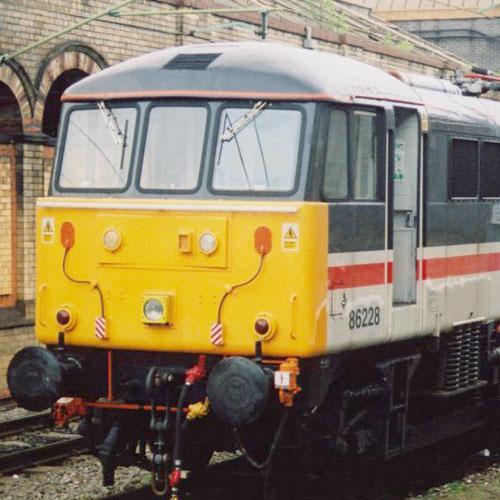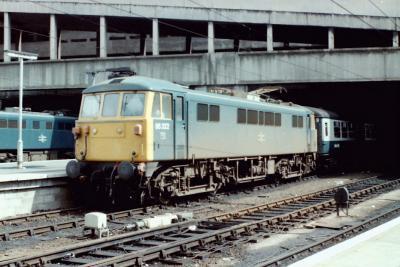The first image is the image on the left, the second image is the image on the right. Evaluate the accuracy of this statement regarding the images: "The area on the front bottom of the train in the image on the left is yellow.". Is it true? Answer yes or no. Yes. The first image is the image on the left, the second image is the image on the right. Assess this claim about the two images: "An image shows a train with a yellow front and a red side stripe, angled heading leftward.". Correct or not? Answer yes or no. Yes. 